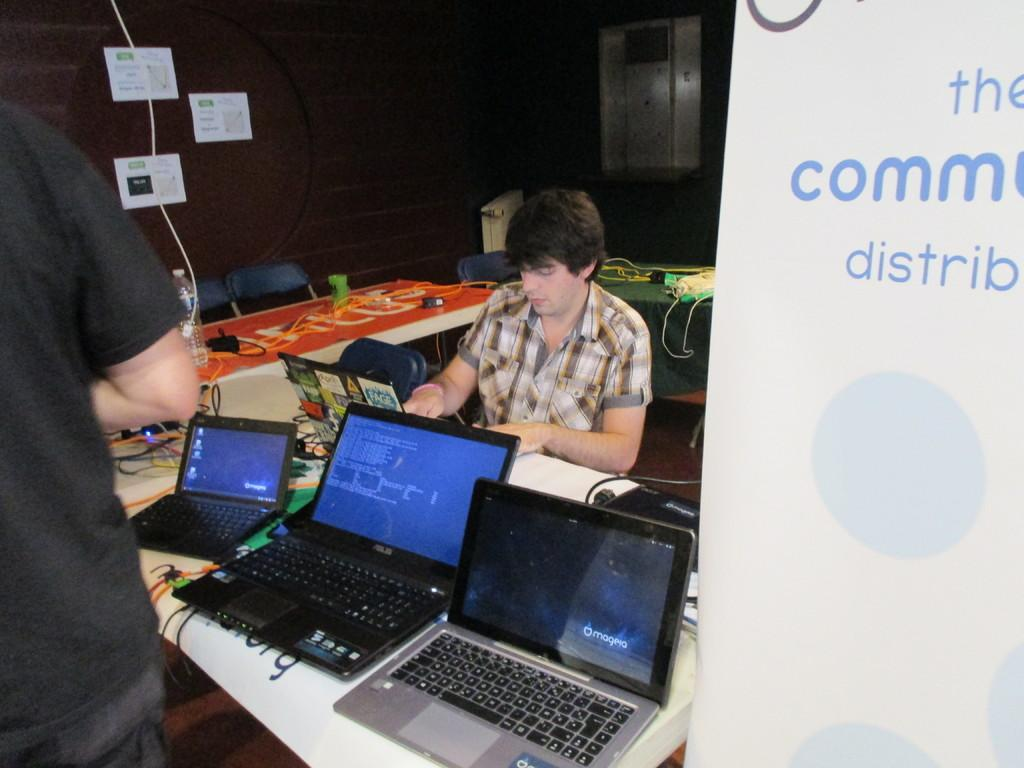<image>
Relay a brief, clear account of the picture shown. Man sitting with laptops and on the right side the word the comm distrib. 